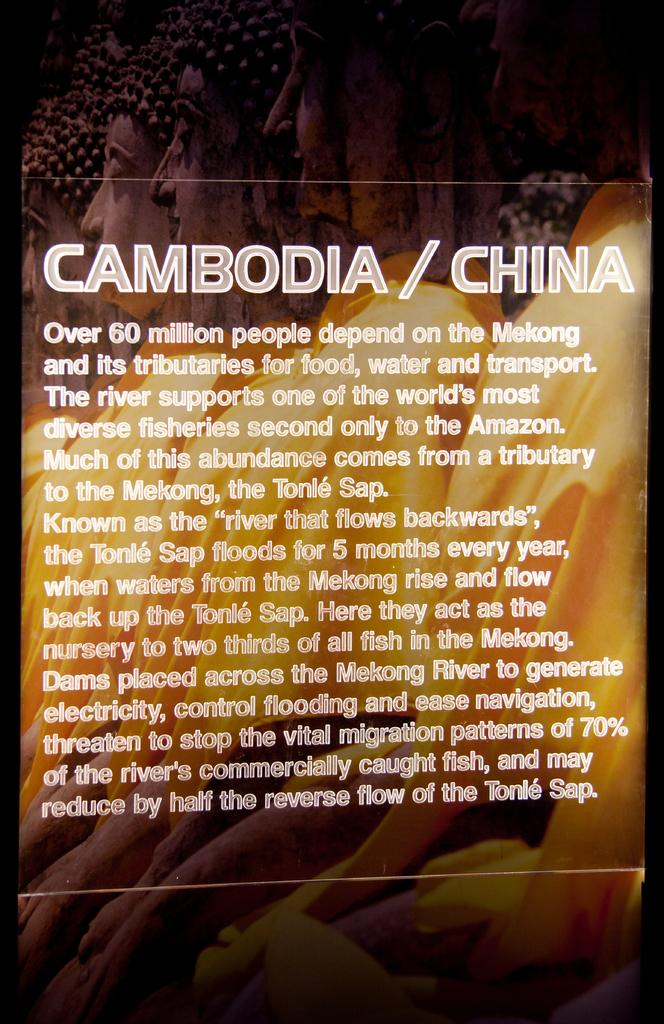<image>
Create a compact narrative representing the image presented. Cambodia/China sign that has a storyline on the front. 